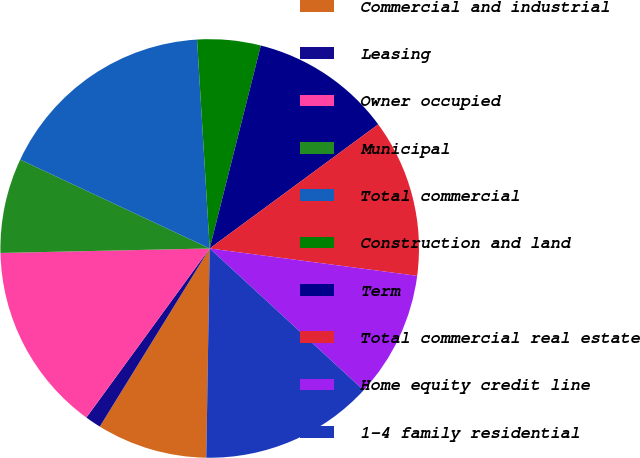Convert chart. <chart><loc_0><loc_0><loc_500><loc_500><pie_chart><fcel>Commercial and industrial<fcel>Leasing<fcel>Owner occupied<fcel>Municipal<fcel>Total commercial<fcel>Construction and land<fcel>Term<fcel>Total commercial real estate<fcel>Home equity credit line<fcel>1-4 family residential<nl><fcel>8.54%<fcel>1.23%<fcel>14.63%<fcel>7.32%<fcel>17.06%<fcel>4.89%<fcel>10.97%<fcel>12.19%<fcel>9.76%<fcel>13.41%<nl></chart> 